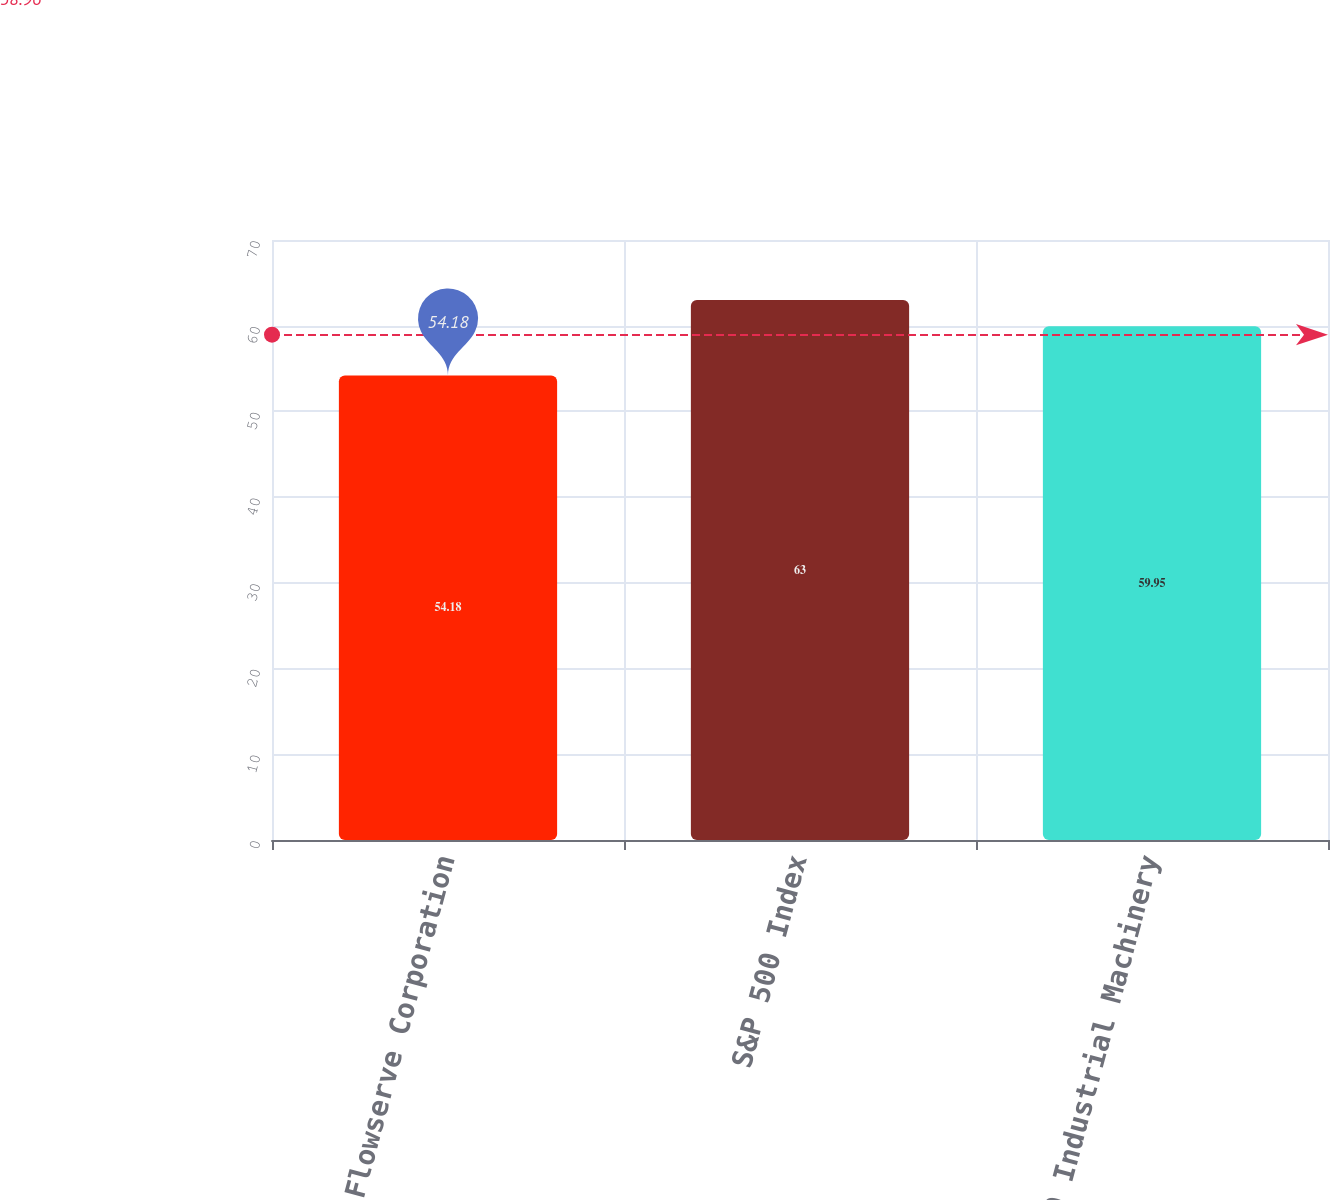Convert chart. <chart><loc_0><loc_0><loc_500><loc_500><bar_chart><fcel>Flowserve Corporation<fcel>S&P 500 Index<fcel>S&P 500 Industrial Machinery<nl><fcel>54.18<fcel>63<fcel>59.95<nl></chart> 